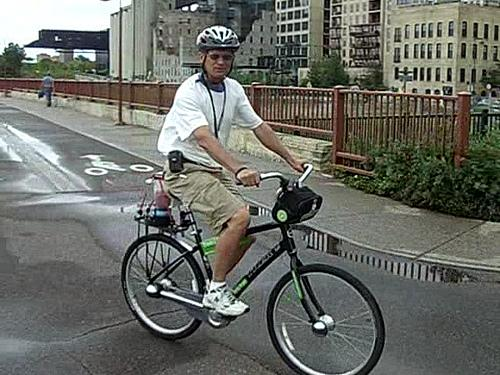What is above the bicycle? man 